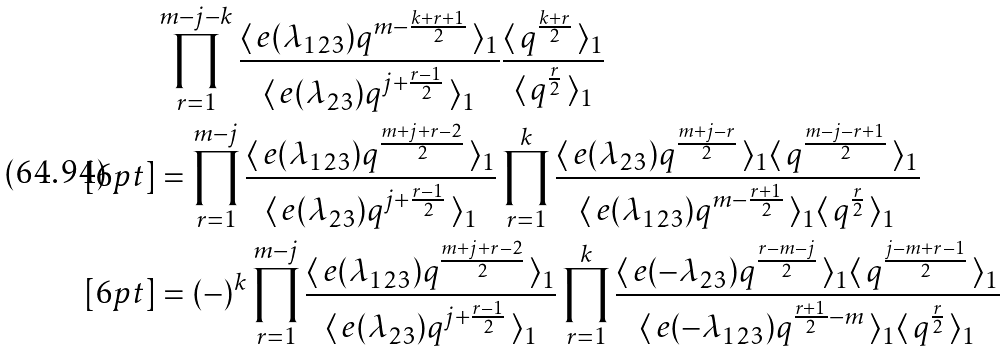<formula> <loc_0><loc_0><loc_500><loc_500>& \prod _ { r = 1 } ^ { m - j - k } \frac { \langle \, e ( \lambda _ { 1 2 3 } ) q ^ { m - \frac { k + r + 1 } { 2 } } \, \rangle _ { 1 } } { \langle \, e ( \lambda _ { 2 3 } ) q ^ { j + \frac { r - 1 } { 2 } } \, \rangle _ { 1 } } \frac { \langle \, q ^ { \frac { k + r } { 2 } } \, \rangle _ { 1 } } { \langle \, q ^ { \frac { r } { 2 } } \, \rangle _ { 1 } } \\ [ 6 p t ] & = \prod _ { r = 1 } ^ { m - j } \frac { \langle \, e ( \lambda _ { 1 2 3 } ) q ^ { \frac { m + j + r - 2 } { 2 } } \, \rangle _ { 1 } } { \langle \, e ( \lambda _ { 2 3 } ) q ^ { j + \frac { r - 1 } { 2 } } \, \rangle _ { 1 } } \prod _ { r = 1 } ^ { k } \frac { \langle \, e ( \lambda _ { 2 3 } ) q ^ { \frac { m + j - r } { 2 } } \, \rangle _ { 1 } \langle \, q ^ { \frac { m - j - r + 1 } { 2 } } \, \rangle _ { 1 } } { \langle \, e ( \lambda _ { 1 2 3 } ) q ^ { m - \frac { r + 1 } { 2 } } \, \rangle _ { 1 } \langle \, q ^ { \frac { r } { 2 } } \, \rangle _ { 1 } } \\ [ 6 p t ] & = ( - ) ^ { k } \prod _ { r = 1 } ^ { m - j } \frac { \langle \, e ( \lambda _ { 1 2 3 } ) q ^ { \frac { m + j + r - 2 } { 2 } } \, \rangle _ { 1 } } { \langle \, e ( \lambda _ { 2 3 } ) q ^ { j + \frac { r - 1 } { 2 } } \, \rangle _ { 1 } } \prod _ { r = 1 } ^ { k } \frac { \langle \, e ( - \lambda _ { 2 3 } ) q ^ { \frac { r - m - j } { 2 } } \, \rangle _ { 1 } \langle \, q ^ { \frac { j - m + r - 1 } { 2 } } \, \rangle _ { 1 } } { \langle \, e ( - \lambda _ { 1 2 3 } ) q ^ { \frac { r + 1 } { 2 } - m } \, \rangle _ { 1 } \langle \, q ^ { \frac { r } { 2 } } \, \rangle _ { 1 } }</formula> 